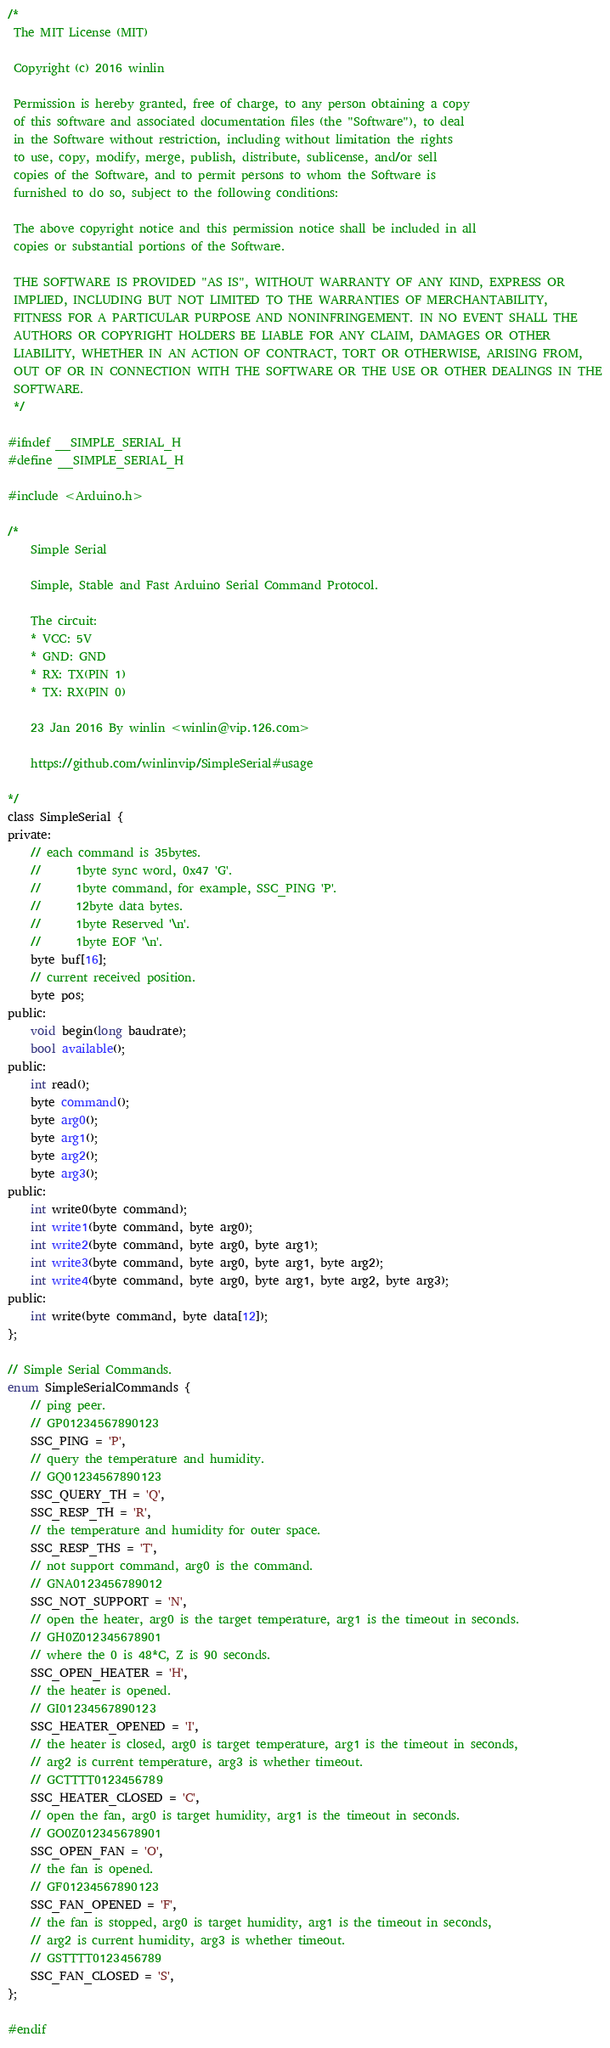<code> <loc_0><loc_0><loc_500><loc_500><_C_>/*
 The MIT License (MIT)
 
 Copyright (c) 2016 winlin
 
 Permission is hereby granted, free of charge, to any person obtaining a copy
 of this software and associated documentation files (the "Software"), to deal
 in the Software without restriction, including without limitation the rights
 to use, copy, modify, merge, publish, distribute, sublicense, and/or sell
 copies of the Software, and to permit persons to whom the Software is
 furnished to do so, subject to the following conditions:
 
 The above copyright notice and this permission notice shall be included in all
 copies or substantial portions of the Software.
 
 THE SOFTWARE IS PROVIDED "AS IS", WITHOUT WARRANTY OF ANY KIND, EXPRESS OR
 IMPLIED, INCLUDING BUT NOT LIMITED TO THE WARRANTIES OF MERCHANTABILITY,
 FITNESS FOR A PARTICULAR PURPOSE AND NONINFRINGEMENT. IN NO EVENT SHALL THE
 AUTHORS OR COPYRIGHT HOLDERS BE LIABLE FOR ANY CLAIM, DAMAGES OR OTHER
 LIABILITY, WHETHER IN AN ACTION OF CONTRACT, TORT OR OTHERWISE, ARISING FROM,
 OUT OF OR IN CONNECTION WITH THE SOFTWARE OR THE USE OR OTHER DEALINGS IN THE
 SOFTWARE.
 */

#ifndef __SIMPLE_SERIAL_H
#define __SIMPLE_SERIAL_H

#include <Arduino.h>

/*
    Simple Serial

    Simple, Stable and Fast Arduino Serial Command Protocol.

    The circuit:
    * VCC: 5V
    * GND: GND
    * RX: TX(PIN 1)
    * TX: RX(PIN 0)

    23 Jan 2016 By winlin <winlin@vip.126.com>

    https://github.com/winlinvip/SimpleSerial#usage

*/
class SimpleSerial {
private:
    // each command is 35bytes.
    //      1byte sync word, 0x47 'G'.
    //      1byte command, for example, SSC_PING 'P'.
    //      12byte data bytes.
    //      1byte Reserved '\n'.
    //      1byte EOF '\n'.
    byte buf[16];
    // current received position.
    byte pos;
public:
    void begin(long baudrate);
    bool available();
public:
    int read();
    byte command();
    byte arg0();
    byte arg1();
    byte arg2();
    byte arg3();
public:
    int write0(byte command);
    int write1(byte command, byte arg0);
    int write2(byte command, byte arg0, byte arg1);
    int write3(byte command, byte arg0, byte arg1, byte arg2);
    int write4(byte command, byte arg0, byte arg1, byte arg2, byte arg3);
public:
    int write(byte command, byte data[12]);
};

// Simple Serial Commands.
enum SimpleSerialCommands {
    // ping peer.
    // GP01234567890123
    SSC_PING = 'P',
    // query the temperature and humidity.
    // GQ01234567890123
    SSC_QUERY_TH = 'Q',
    SSC_RESP_TH = 'R',
    // the temperature and humidity for outer space.
    SSC_RESP_THS = 'T',
    // not support command, arg0 is the command.
    // GNA0123456789012
    SSC_NOT_SUPPORT = 'N',
    // open the heater, arg0 is the target temperature, arg1 is the timeout in seconds.
    // GH0Z012345678901
    // where the 0 is 48*C, Z is 90 seconds.
    SSC_OPEN_HEATER = 'H',
    // the heater is opened.
    // GI01234567890123
    SSC_HEATER_OPENED = 'I',
    // the heater is closed, arg0 is target temperature, arg1 is the timeout in seconds, 
    // arg2 is current temperature, arg3 is whether timeout.
    // GCTTTT0123456789
    SSC_HEATER_CLOSED = 'C',
    // open the fan, arg0 is target humidity, arg1 is the timeout in seconds.
    // GO0Z012345678901
    SSC_OPEN_FAN = 'O',
    // the fan is opened. 
    // GF01234567890123
    SSC_FAN_OPENED = 'F',
    // the fan is stopped, arg0 is target humidity, arg1 is the timeout in seconds, 
    // arg2 is current humidity, arg3 is whether timeout.
    // GSTTTT0123456789
    SSC_FAN_CLOSED = 'S',
};

#endif
</code> 